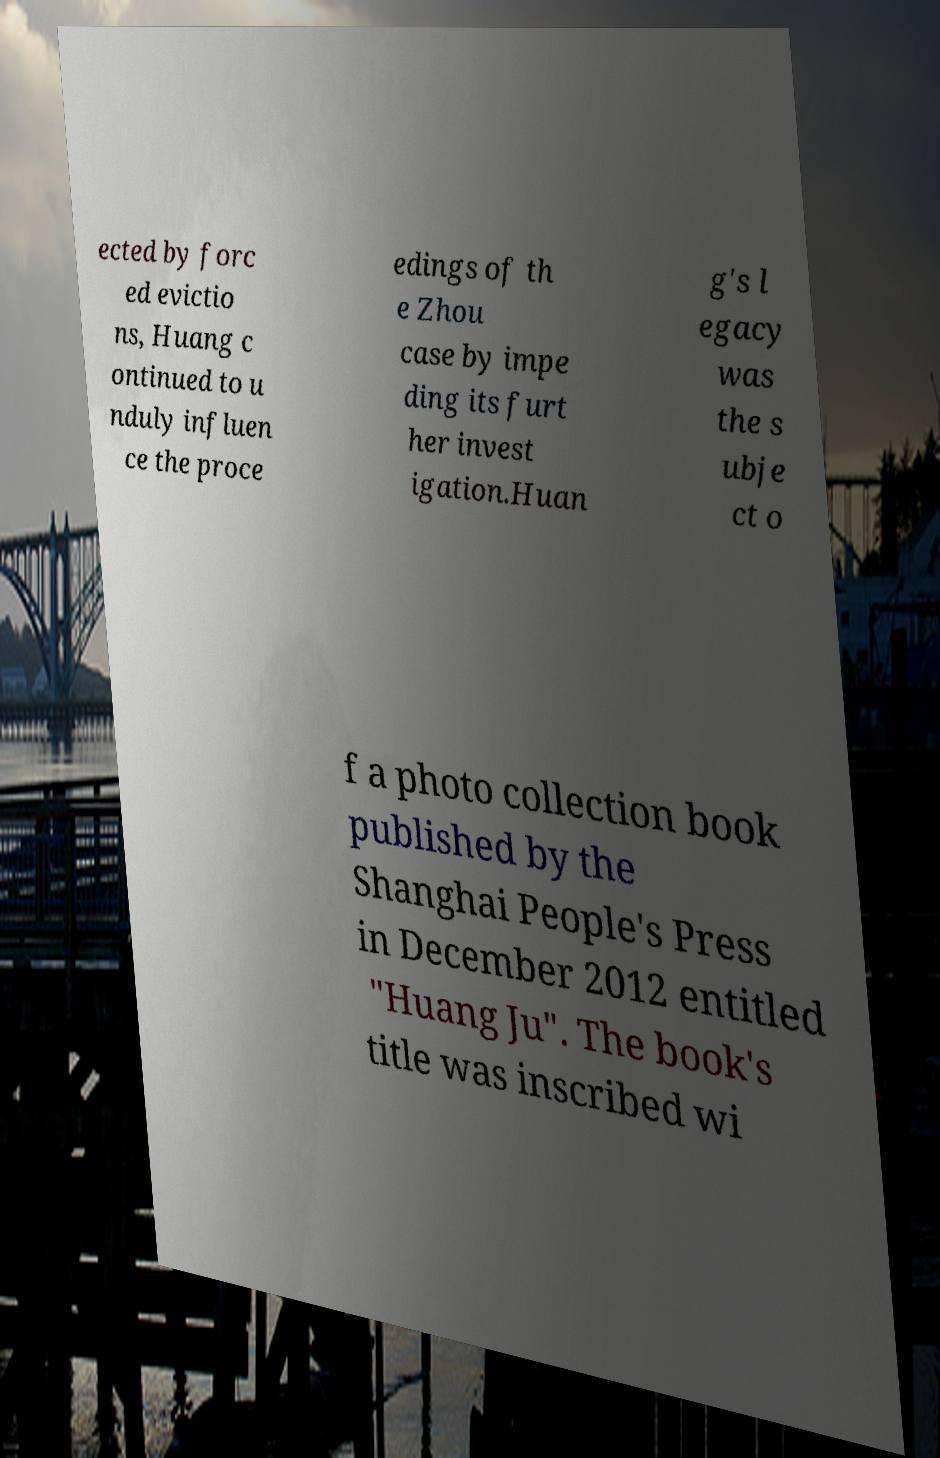Please identify and transcribe the text found in this image. ected by forc ed evictio ns, Huang c ontinued to u nduly influen ce the proce edings of th e Zhou case by impe ding its furt her invest igation.Huan g's l egacy was the s ubje ct o f a photo collection book published by the Shanghai People's Press in December 2012 entitled "Huang Ju". The book's title was inscribed wi 